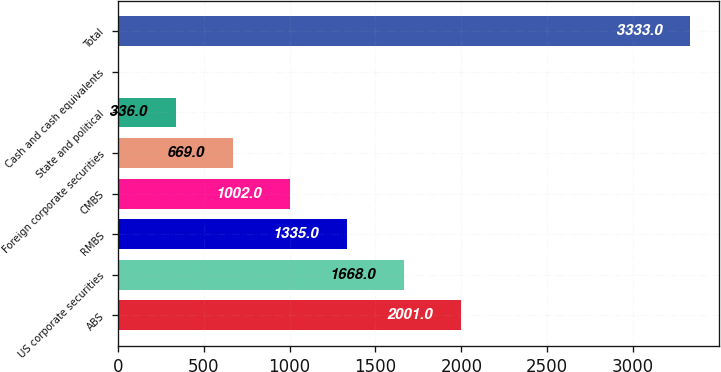Convert chart to OTSL. <chart><loc_0><loc_0><loc_500><loc_500><bar_chart><fcel>ABS<fcel>US corporate securities<fcel>RMBS<fcel>CMBS<fcel>Foreign corporate securities<fcel>State and political<fcel>Cash and cash equivalents<fcel>Total<nl><fcel>2001<fcel>1668<fcel>1335<fcel>1002<fcel>669<fcel>336<fcel>3<fcel>3333<nl></chart> 